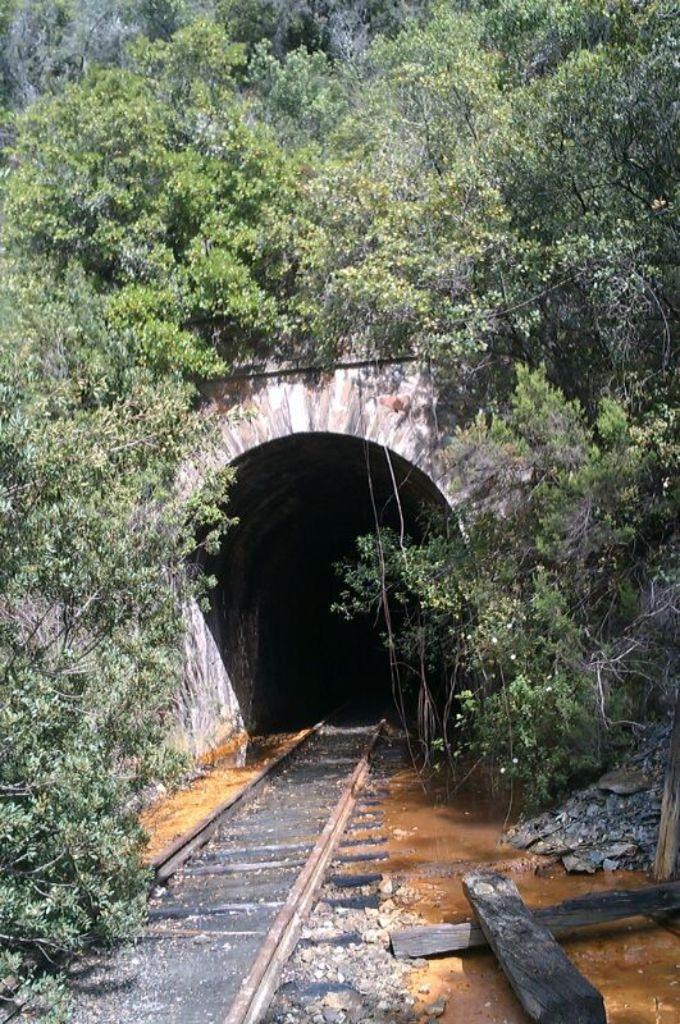What type of pathway is visible in the image? There is a track in the image. What structures can be seen supporting the track? There are wooden poles in the image. What type of vegetation is present in the image? There are plants and trees in the image. What type of passageway is visible in the image? There is a tunnel in the image. What type of magic is being performed in the image? There is no magic or any indication of a magical performance in the image. What sound can be heard coming from the tunnel in the image? The image is silent, and no sounds can be heard. 